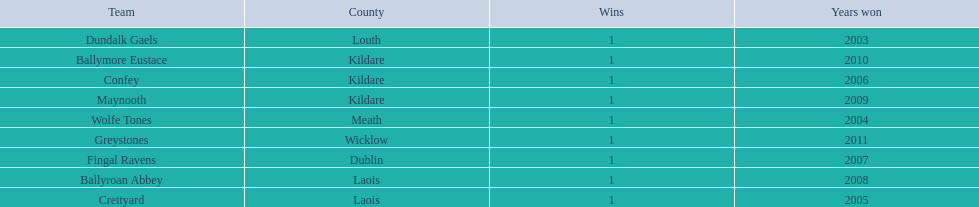Where is ballymore eustace from? Kildare. What teams other than ballymore eustace is from kildare? Maynooth, Confey. Between maynooth and confey, which won in 2009? Maynooth. Help me parse the entirety of this table. {'header': ['Team', 'County', 'Wins', 'Years won'], 'rows': [['Dundalk Gaels', 'Louth', '1', '2003'], ['Ballymore Eustace', 'Kildare', '1', '2010'], ['Confey', 'Kildare', '1', '2006'], ['Maynooth', 'Kildare', '1', '2009'], ['Wolfe Tones', 'Meath', '1', '2004'], ['Greystones', 'Wicklow', '1', '2011'], ['Fingal Ravens', 'Dublin', '1', '2007'], ['Ballyroan Abbey', 'Laois', '1', '2008'], ['Crettyard', 'Laois', '1', '2005']]} 